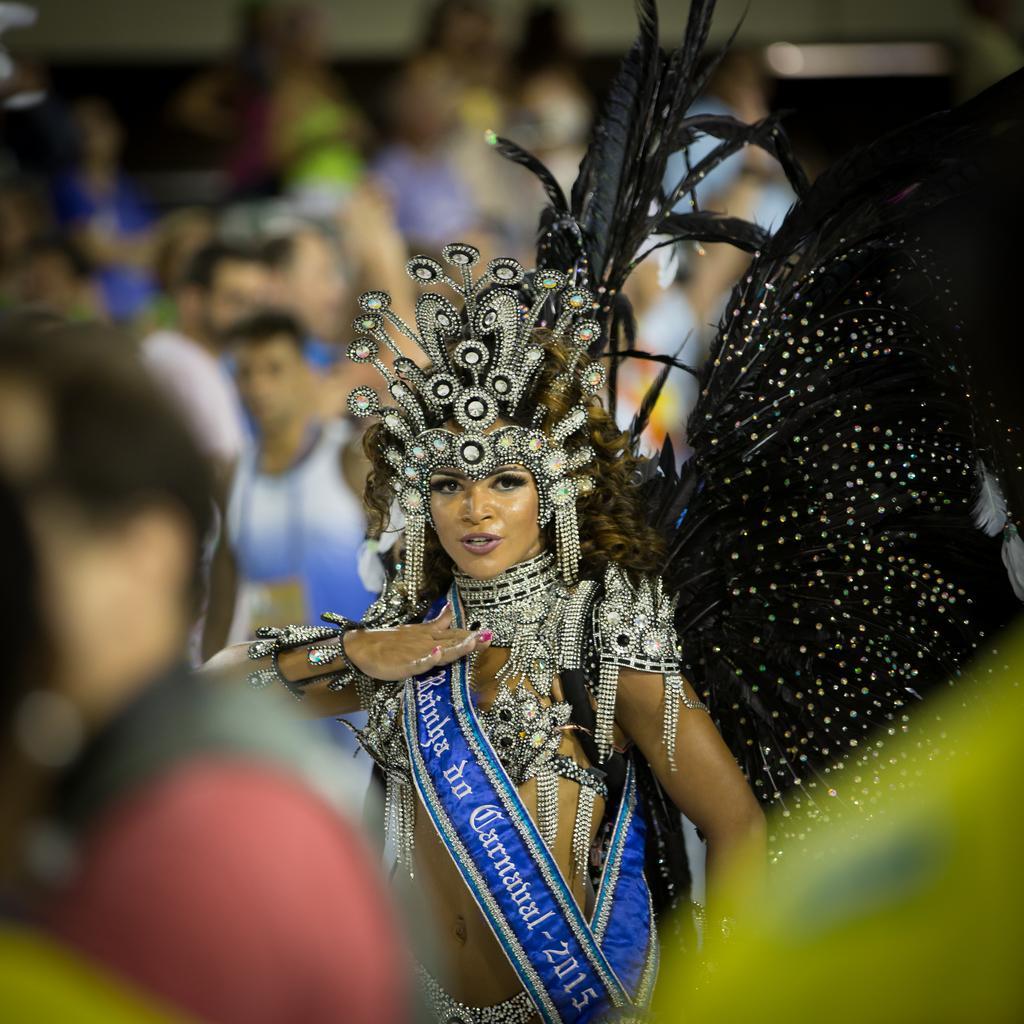Could you give a brief overview of what you see in this image? In this image we can see a lady with a costume. And she is wearing a shah with text and number. In the background we can see people and it is blurry. 